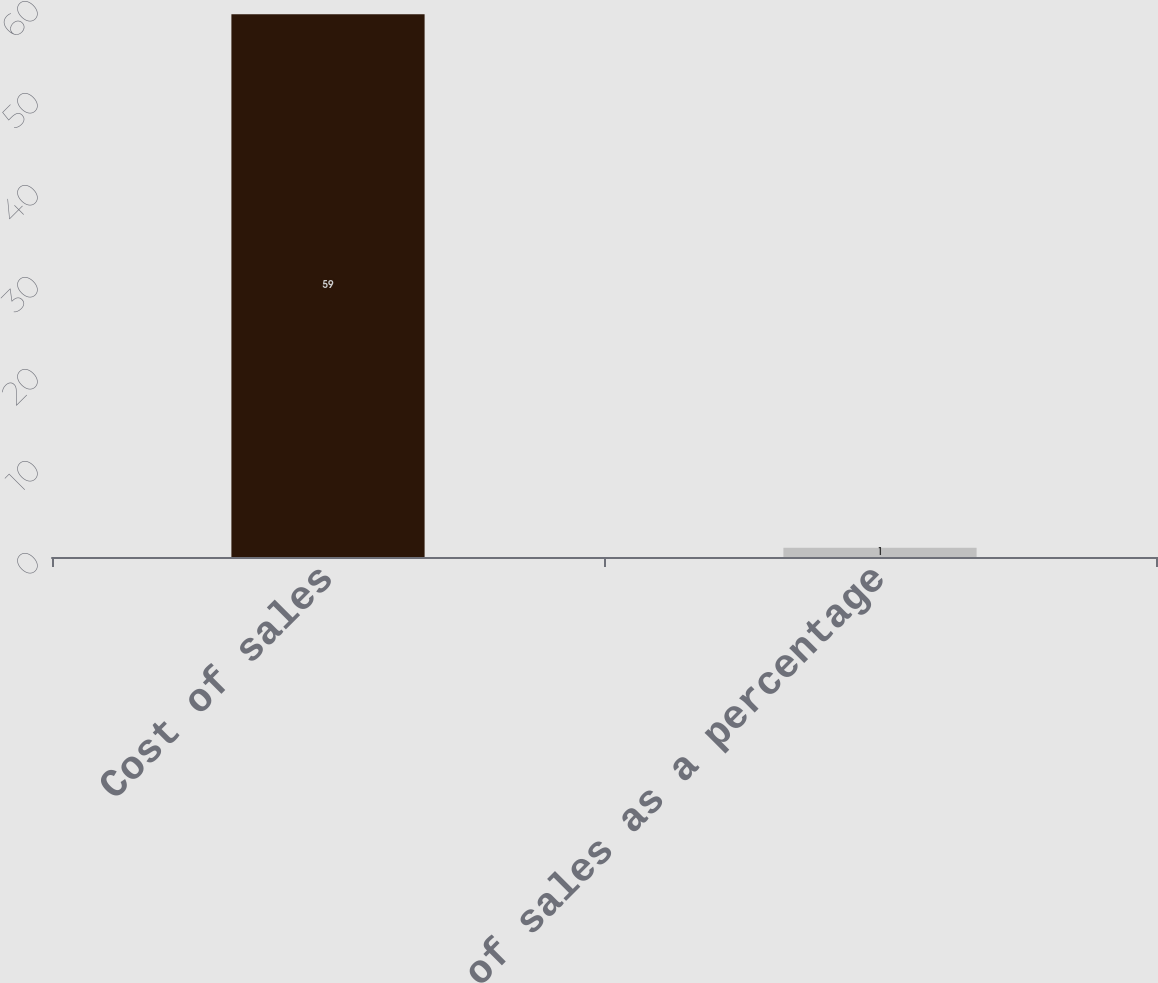Convert chart to OTSL. <chart><loc_0><loc_0><loc_500><loc_500><bar_chart><fcel>Cost of sales<fcel>Cost of sales as a percentage<nl><fcel>59<fcel>1<nl></chart> 